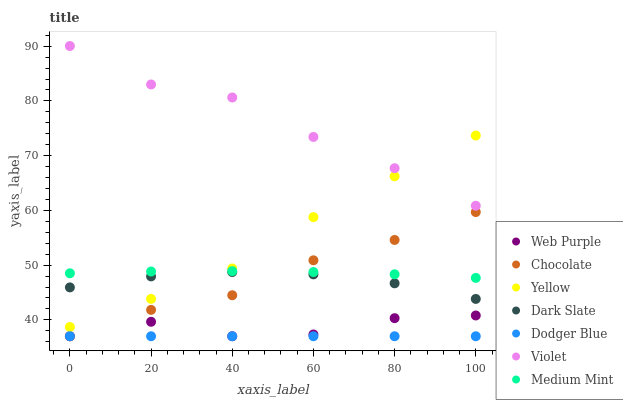Does Dodger Blue have the minimum area under the curve?
Answer yes or no. Yes. Does Violet have the maximum area under the curve?
Answer yes or no. Yes. Does Yellow have the minimum area under the curve?
Answer yes or no. No. Does Yellow have the maximum area under the curve?
Answer yes or no. No. Is Dodger Blue the smoothest?
Answer yes or no. Yes. Is Web Purple the roughest?
Answer yes or no. Yes. Is Yellow the smoothest?
Answer yes or no. No. Is Yellow the roughest?
Answer yes or no. No. Does Chocolate have the lowest value?
Answer yes or no. Yes. Does Yellow have the lowest value?
Answer yes or no. No. Does Violet have the highest value?
Answer yes or no. Yes. Does Yellow have the highest value?
Answer yes or no. No. Is Dark Slate less than Medium Mint?
Answer yes or no. Yes. Is Yellow greater than Chocolate?
Answer yes or no. Yes. Does Chocolate intersect Medium Mint?
Answer yes or no. Yes. Is Chocolate less than Medium Mint?
Answer yes or no. No. Is Chocolate greater than Medium Mint?
Answer yes or no. No. Does Dark Slate intersect Medium Mint?
Answer yes or no. No. 